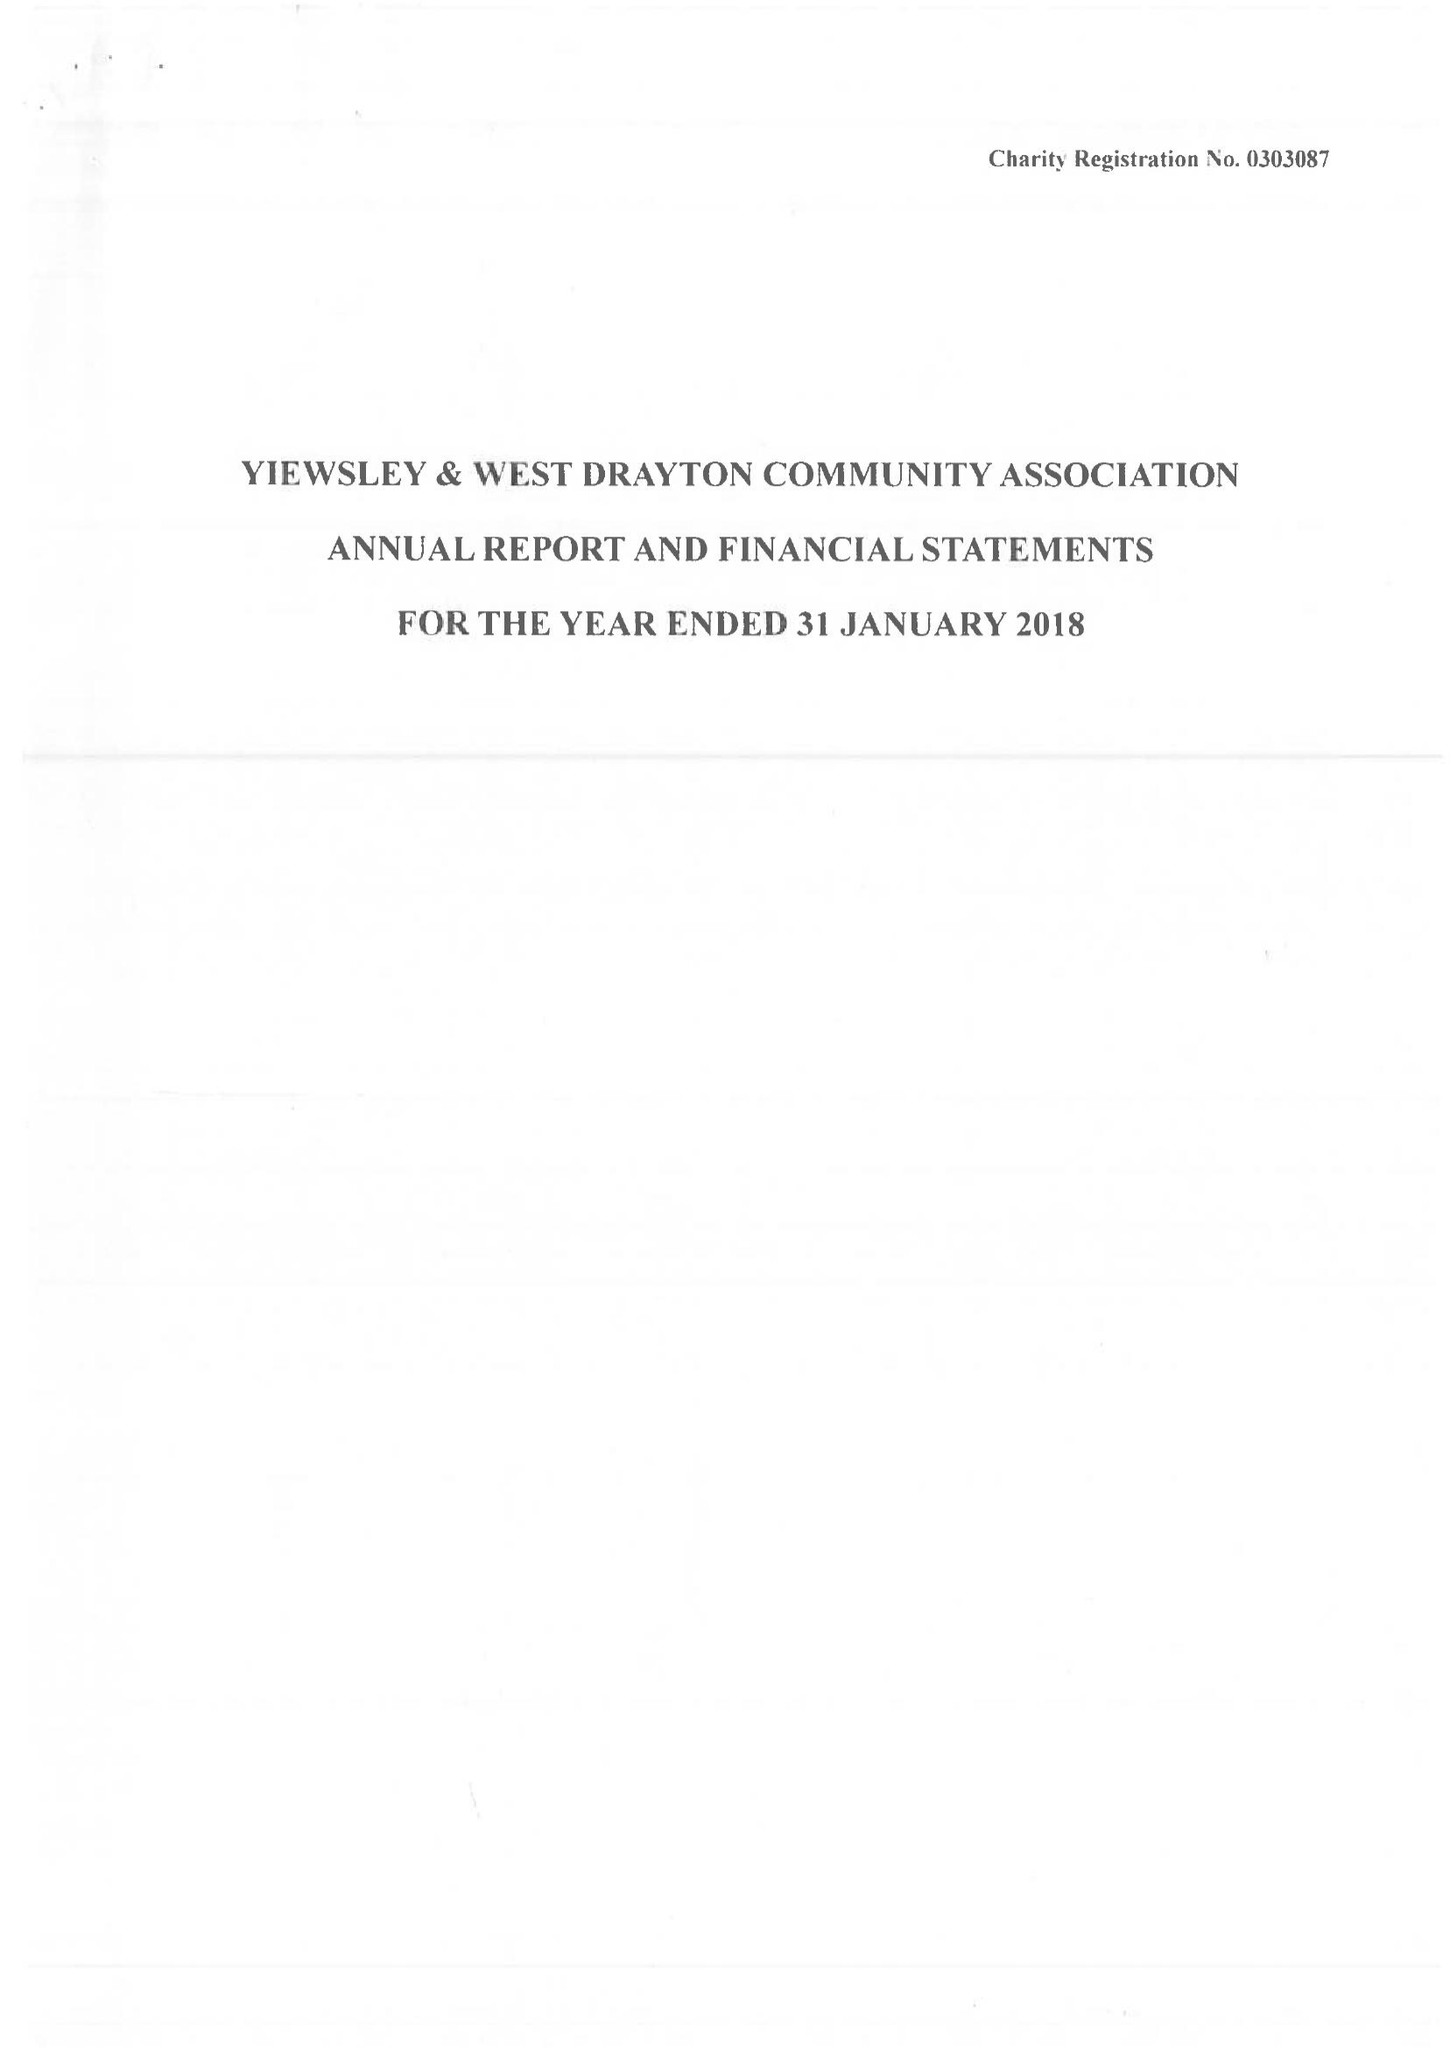What is the value for the spending_annually_in_british_pounds?
Answer the question using a single word or phrase. 141686.00 